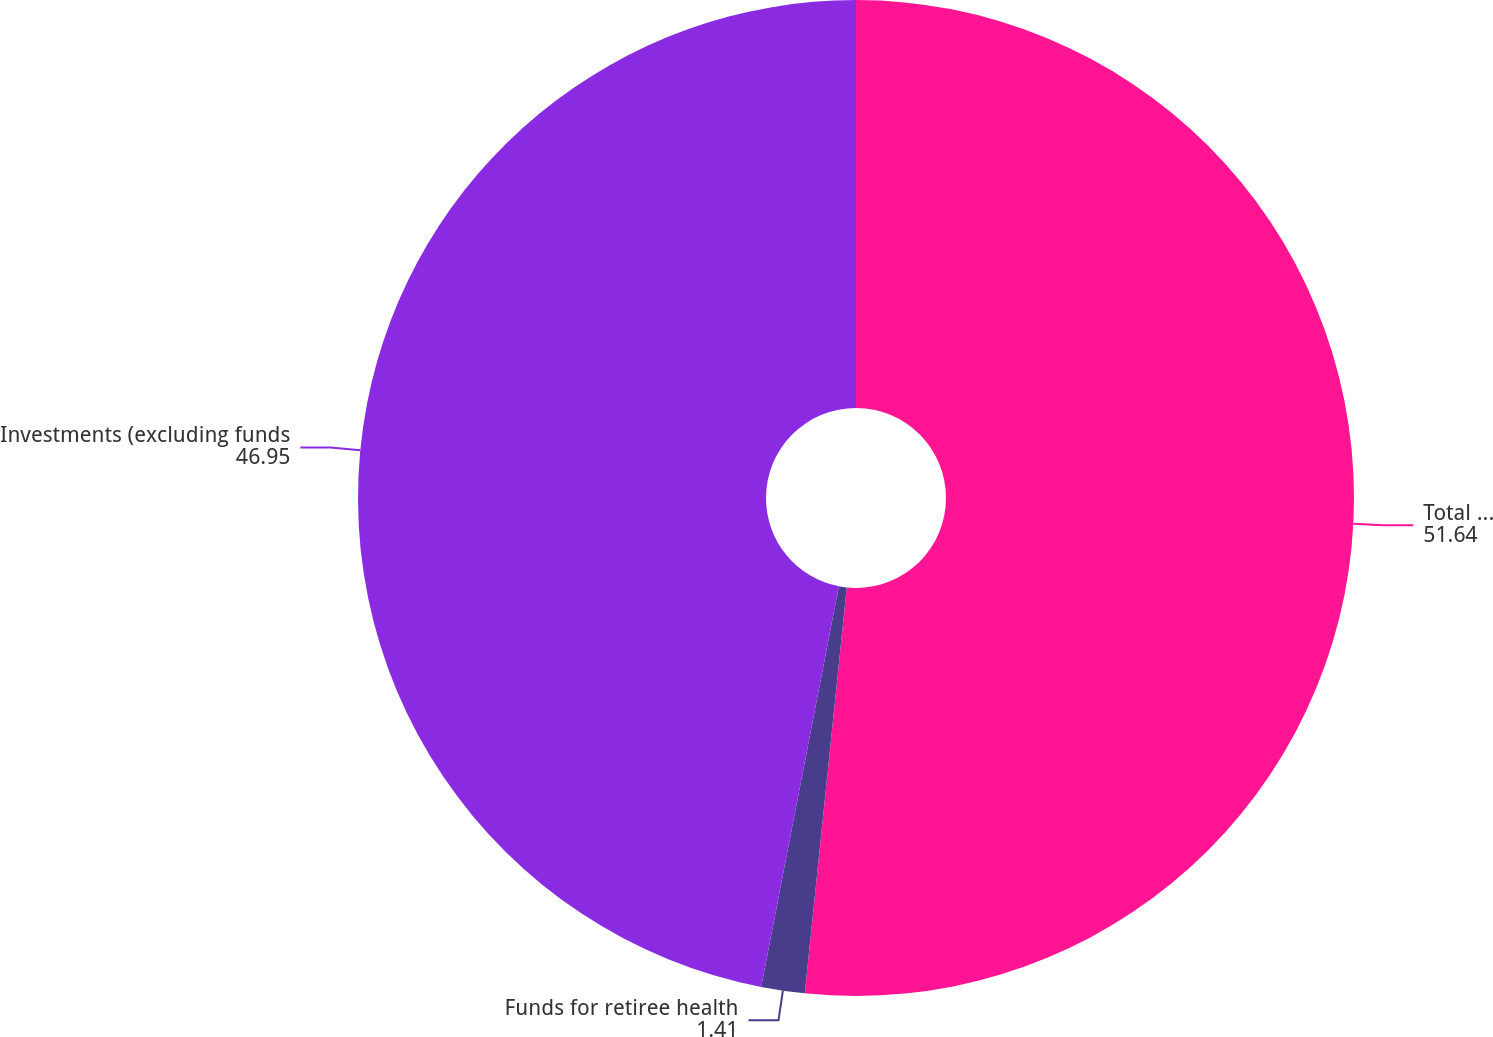Convert chart to OTSL. <chart><loc_0><loc_0><loc_500><loc_500><pie_chart><fcel>Total investments<fcel>Funds for retiree health<fcel>Investments (excluding funds<nl><fcel>51.64%<fcel>1.41%<fcel>46.95%<nl></chart> 